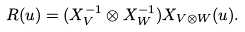<formula> <loc_0><loc_0><loc_500><loc_500>R ( u ) = ( X _ { V } ^ { - 1 } \otimes X _ { W } ^ { - 1 } ) X _ { V \otimes W } ( u ) .</formula> 